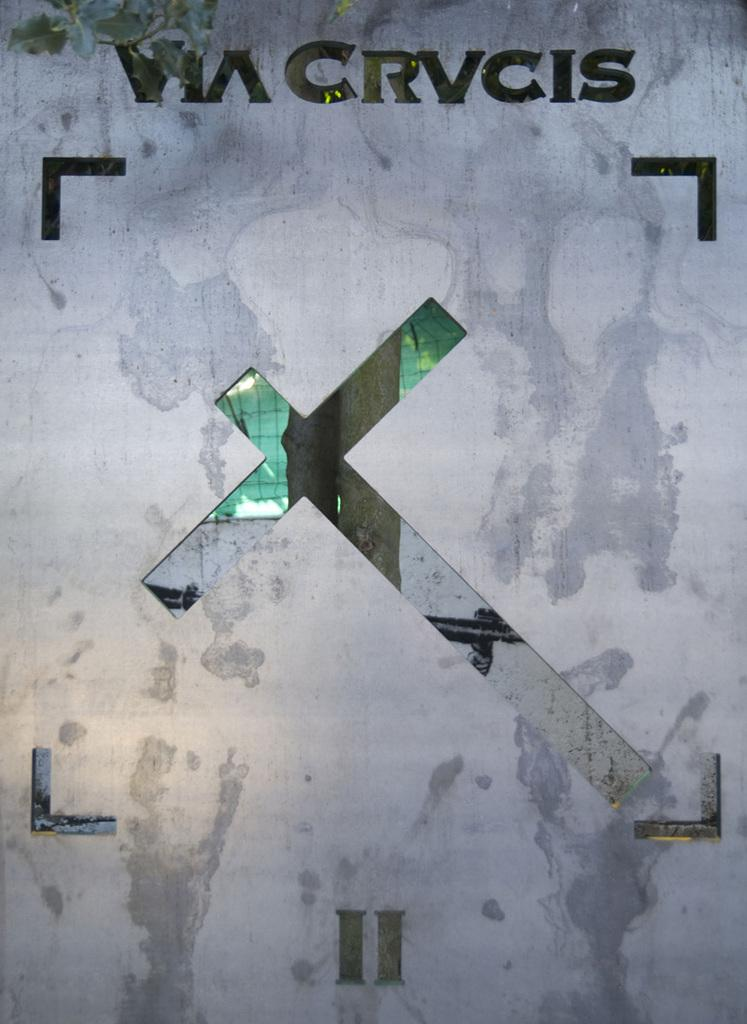<image>
Offer a succinct explanation of the picture presented. grau background with stain patterns and a sideways cross and letters at top VIA CRVCIS and II at bottom 